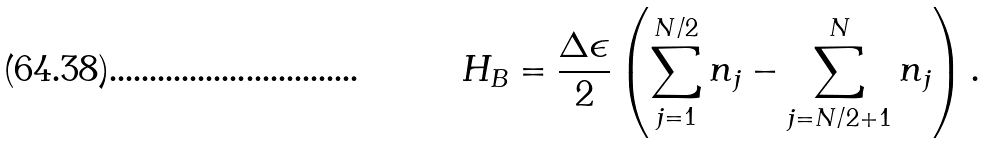Convert formula to latex. <formula><loc_0><loc_0><loc_500><loc_500>H _ { B } = \frac { \Delta \epsilon } { 2 } \left ( \sum _ { j = 1 } ^ { N / 2 } n _ { j } - \sum _ { j = N / 2 + 1 } ^ { N } n _ { j } \right ) .</formula> 